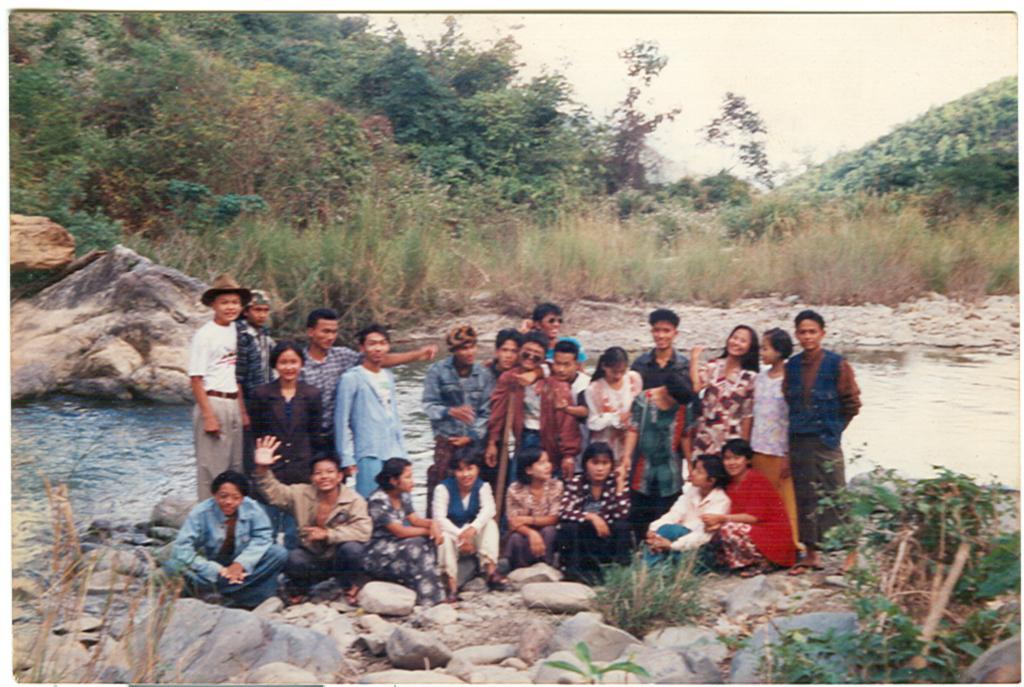Can you describe this image briefly? This is a photograph. In this we can see few persons are sitting on the stones and behind them few persons are standing and among them a boy is having a hat on his head. In the background we can see water,grass,stones,plants,trees and sky. 